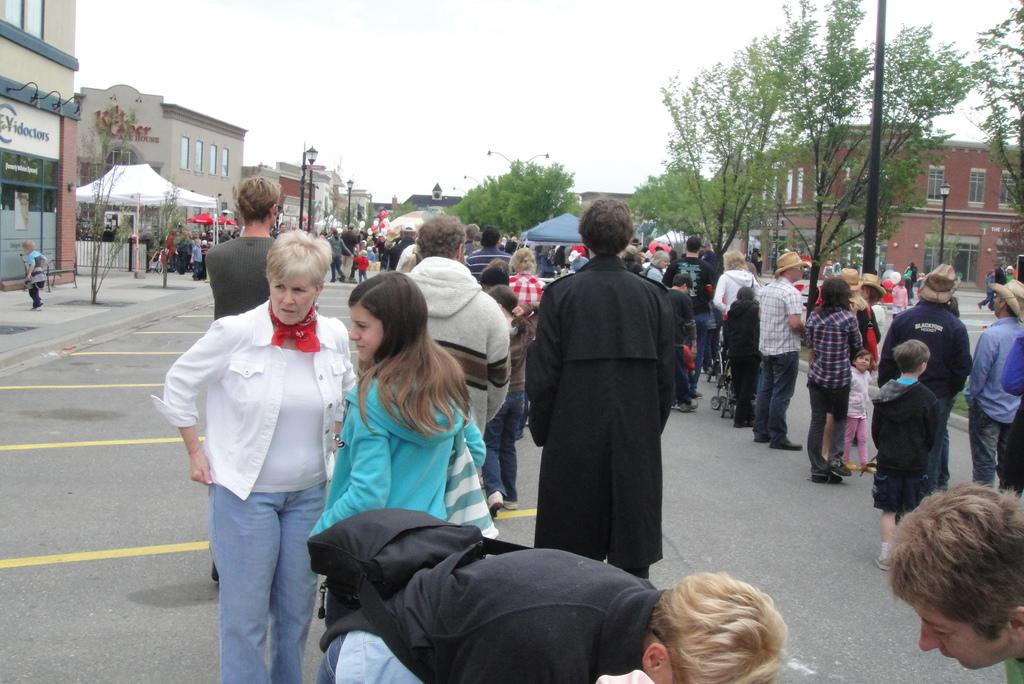What is happening on the road in the image? There is a group of people on the road in the image. What can be seen in the background of the image? There are trees, buildings, and street lamps in the background of the image. What is visible at the top of the image? The sky is visible at the top of the image. What color is the silver toe on the coast in the image? There is no silver toe or coast present in the image. 